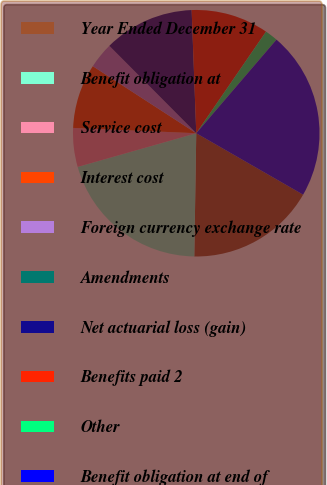Convert chart to OTSL. <chart><loc_0><loc_0><loc_500><loc_500><pie_chart><fcel>Year Ended December 31<fcel>Benefit obligation at<fcel>Service cost<fcel>Interest cost<fcel>Foreign currency exchange rate<fcel>Amendments<fcel>Net actuarial loss (gain)<fcel>Benefits paid 2<fcel>Other<fcel>Benefit obligation at end of<nl><fcel>16.95%<fcel>20.34%<fcel>5.09%<fcel>8.47%<fcel>3.39%<fcel>0.0%<fcel>11.86%<fcel>10.17%<fcel>1.7%<fcel>22.03%<nl></chart> 